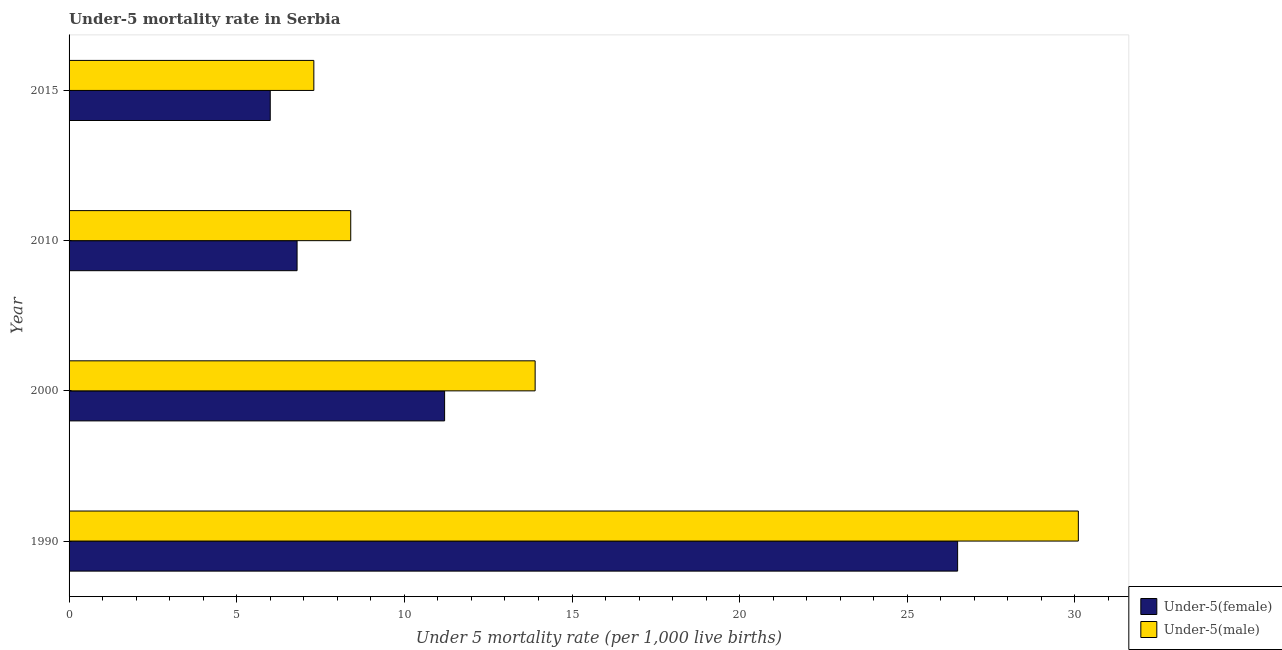How many bars are there on the 3rd tick from the bottom?
Offer a terse response. 2. What is the under-5 male mortality rate in 2000?
Make the answer very short. 13.9. Across all years, what is the maximum under-5 male mortality rate?
Your answer should be very brief. 30.1. In which year was the under-5 female mortality rate minimum?
Your response must be concise. 2015. What is the total under-5 female mortality rate in the graph?
Give a very brief answer. 50.5. What is the difference between the under-5 male mortality rate in 1990 and that in 2000?
Ensure brevity in your answer.  16.2. What is the difference between the under-5 male mortality rate in 2015 and the under-5 female mortality rate in 2000?
Offer a very short reply. -3.9. What is the average under-5 male mortality rate per year?
Keep it short and to the point. 14.93. In the year 2010, what is the difference between the under-5 male mortality rate and under-5 female mortality rate?
Your answer should be very brief. 1.6. What is the ratio of the under-5 female mortality rate in 1990 to that in 2010?
Provide a short and direct response. 3.9. Is the difference between the under-5 female mortality rate in 2010 and 2015 greater than the difference between the under-5 male mortality rate in 2010 and 2015?
Make the answer very short. No. What is the difference between the highest and the second highest under-5 male mortality rate?
Your answer should be very brief. 16.2. What is the difference between the highest and the lowest under-5 female mortality rate?
Give a very brief answer. 20.5. In how many years, is the under-5 male mortality rate greater than the average under-5 male mortality rate taken over all years?
Keep it short and to the point. 1. Is the sum of the under-5 male mortality rate in 1990 and 2010 greater than the maximum under-5 female mortality rate across all years?
Offer a very short reply. Yes. What does the 1st bar from the top in 1990 represents?
Provide a short and direct response. Under-5(male). What does the 1st bar from the bottom in 2015 represents?
Offer a very short reply. Under-5(female). How many bars are there?
Your answer should be compact. 8. Are all the bars in the graph horizontal?
Provide a succinct answer. Yes. What is the difference between two consecutive major ticks on the X-axis?
Provide a short and direct response. 5. Are the values on the major ticks of X-axis written in scientific E-notation?
Give a very brief answer. No. Does the graph contain any zero values?
Give a very brief answer. No. Where does the legend appear in the graph?
Give a very brief answer. Bottom right. How many legend labels are there?
Provide a succinct answer. 2. How are the legend labels stacked?
Give a very brief answer. Vertical. What is the title of the graph?
Your answer should be very brief. Under-5 mortality rate in Serbia. Does "Services" appear as one of the legend labels in the graph?
Your answer should be very brief. No. What is the label or title of the X-axis?
Make the answer very short. Under 5 mortality rate (per 1,0 live births). What is the Under 5 mortality rate (per 1,000 live births) in Under-5(male) in 1990?
Ensure brevity in your answer.  30.1. What is the Under 5 mortality rate (per 1,000 live births) in Under-5(female) in 2000?
Make the answer very short. 11.2. What is the Under 5 mortality rate (per 1,000 live births) of Under-5(male) in 2010?
Provide a succinct answer. 8.4. What is the Under 5 mortality rate (per 1,000 live births) in Under-5(female) in 2015?
Give a very brief answer. 6. Across all years, what is the maximum Under 5 mortality rate (per 1,000 live births) in Under-5(male)?
Keep it short and to the point. 30.1. Across all years, what is the minimum Under 5 mortality rate (per 1,000 live births) of Under-5(female)?
Ensure brevity in your answer.  6. Across all years, what is the minimum Under 5 mortality rate (per 1,000 live births) in Under-5(male)?
Your answer should be compact. 7.3. What is the total Under 5 mortality rate (per 1,000 live births) of Under-5(female) in the graph?
Your answer should be compact. 50.5. What is the total Under 5 mortality rate (per 1,000 live births) of Under-5(male) in the graph?
Provide a short and direct response. 59.7. What is the difference between the Under 5 mortality rate (per 1,000 live births) of Under-5(male) in 1990 and that in 2000?
Keep it short and to the point. 16.2. What is the difference between the Under 5 mortality rate (per 1,000 live births) in Under-5(male) in 1990 and that in 2010?
Keep it short and to the point. 21.7. What is the difference between the Under 5 mortality rate (per 1,000 live births) in Under-5(male) in 1990 and that in 2015?
Offer a terse response. 22.8. What is the difference between the Under 5 mortality rate (per 1,000 live births) of Under-5(female) in 2000 and that in 2010?
Keep it short and to the point. 4.4. What is the difference between the Under 5 mortality rate (per 1,000 live births) of Under-5(male) in 2000 and that in 2015?
Offer a terse response. 6.6. What is the difference between the Under 5 mortality rate (per 1,000 live births) of Under-5(female) in 1990 and the Under 5 mortality rate (per 1,000 live births) of Under-5(male) in 2000?
Provide a succinct answer. 12.6. What is the difference between the Under 5 mortality rate (per 1,000 live births) in Under-5(female) in 1990 and the Under 5 mortality rate (per 1,000 live births) in Under-5(male) in 2010?
Your answer should be compact. 18.1. What is the difference between the Under 5 mortality rate (per 1,000 live births) of Under-5(female) in 2000 and the Under 5 mortality rate (per 1,000 live births) of Under-5(male) in 2015?
Keep it short and to the point. 3.9. What is the difference between the Under 5 mortality rate (per 1,000 live births) in Under-5(female) in 2010 and the Under 5 mortality rate (per 1,000 live births) in Under-5(male) in 2015?
Give a very brief answer. -0.5. What is the average Under 5 mortality rate (per 1,000 live births) in Under-5(female) per year?
Your answer should be compact. 12.62. What is the average Under 5 mortality rate (per 1,000 live births) of Under-5(male) per year?
Provide a succinct answer. 14.93. In the year 2010, what is the difference between the Under 5 mortality rate (per 1,000 live births) in Under-5(female) and Under 5 mortality rate (per 1,000 live births) in Under-5(male)?
Provide a short and direct response. -1.6. What is the ratio of the Under 5 mortality rate (per 1,000 live births) of Under-5(female) in 1990 to that in 2000?
Make the answer very short. 2.37. What is the ratio of the Under 5 mortality rate (per 1,000 live births) of Under-5(male) in 1990 to that in 2000?
Ensure brevity in your answer.  2.17. What is the ratio of the Under 5 mortality rate (per 1,000 live births) of Under-5(female) in 1990 to that in 2010?
Your answer should be very brief. 3.9. What is the ratio of the Under 5 mortality rate (per 1,000 live births) of Under-5(male) in 1990 to that in 2010?
Your answer should be compact. 3.58. What is the ratio of the Under 5 mortality rate (per 1,000 live births) in Under-5(female) in 1990 to that in 2015?
Give a very brief answer. 4.42. What is the ratio of the Under 5 mortality rate (per 1,000 live births) in Under-5(male) in 1990 to that in 2015?
Your answer should be very brief. 4.12. What is the ratio of the Under 5 mortality rate (per 1,000 live births) of Under-5(female) in 2000 to that in 2010?
Keep it short and to the point. 1.65. What is the ratio of the Under 5 mortality rate (per 1,000 live births) of Under-5(male) in 2000 to that in 2010?
Ensure brevity in your answer.  1.65. What is the ratio of the Under 5 mortality rate (per 1,000 live births) of Under-5(female) in 2000 to that in 2015?
Keep it short and to the point. 1.87. What is the ratio of the Under 5 mortality rate (per 1,000 live births) in Under-5(male) in 2000 to that in 2015?
Keep it short and to the point. 1.9. What is the ratio of the Under 5 mortality rate (per 1,000 live births) of Under-5(female) in 2010 to that in 2015?
Offer a very short reply. 1.13. What is the ratio of the Under 5 mortality rate (per 1,000 live births) in Under-5(male) in 2010 to that in 2015?
Your answer should be compact. 1.15. What is the difference between the highest and the lowest Under 5 mortality rate (per 1,000 live births) in Under-5(female)?
Your answer should be very brief. 20.5. What is the difference between the highest and the lowest Under 5 mortality rate (per 1,000 live births) of Under-5(male)?
Your response must be concise. 22.8. 